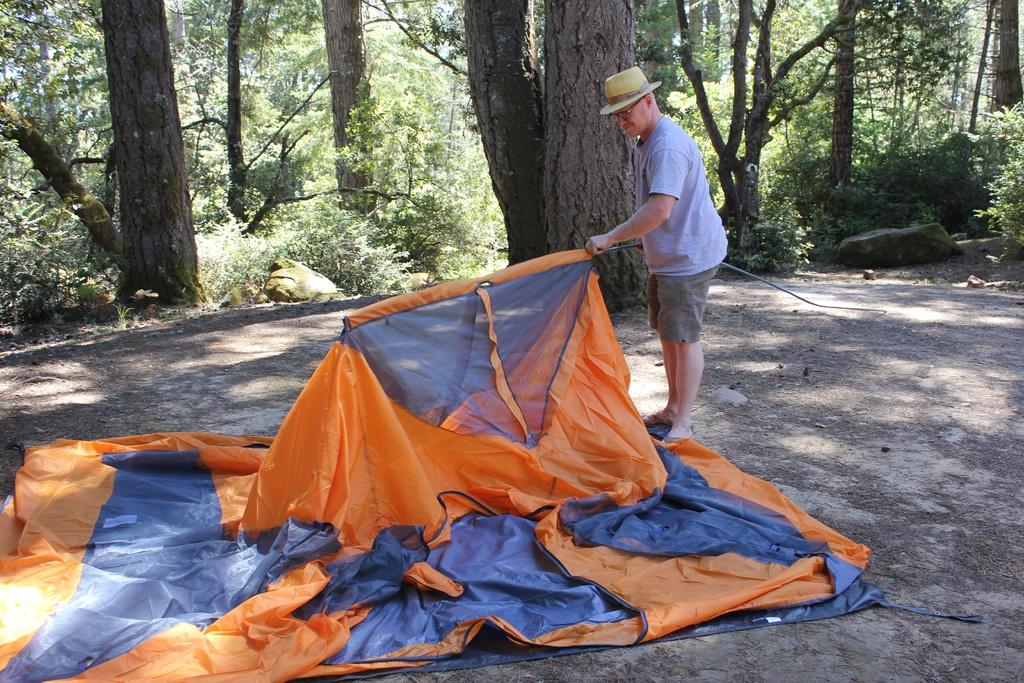What is the main subject of the image? There is a man in the image. What is the man doing in the image? The man is standing in the image. Can you describe the man's attire? The man is wearing a hat and spectacles in the image. What is the man holding in the image? The man is holding an object in the image. What type of material is visible in the image? There is cloth visible in the image. What can be seen in the background of the image? There are trees and rocks in the background of the image. What type of smile can be seen on the man's face in the image? There is no smile visible on the man's face in the image. What company does the man work for, as indicated by the object he is holding? The object the man is holding does not indicate any company affiliation. 